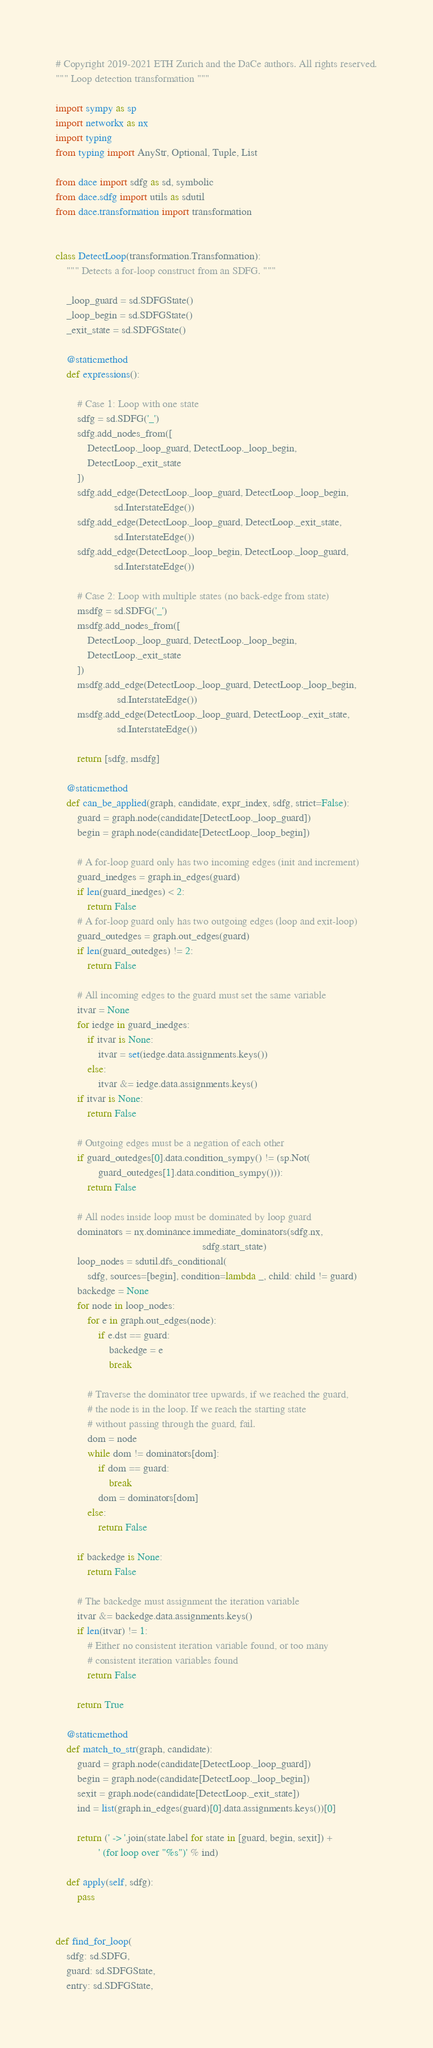Convert code to text. <code><loc_0><loc_0><loc_500><loc_500><_Python_># Copyright 2019-2021 ETH Zurich and the DaCe authors. All rights reserved.
""" Loop detection transformation """

import sympy as sp
import networkx as nx
import typing
from typing import AnyStr, Optional, Tuple, List

from dace import sdfg as sd, symbolic
from dace.sdfg import utils as sdutil
from dace.transformation import transformation


class DetectLoop(transformation.Transformation):
    """ Detects a for-loop construct from an SDFG. """

    _loop_guard = sd.SDFGState()
    _loop_begin = sd.SDFGState()
    _exit_state = sd.SDFGState()

    @staticmethod
    def expressions():

        # Case 1: Loop with one state
        sdfg = sd.SDFG('_')
        sdfg.add_nodes_from([
            DetectLoop._loop_guard, DetectLoop._loop_begin,
            DetectLoop._exit_state
        ])
        sdfg.add_edge(DetectLoop._loop_guard, DetectLoop._loop_begin,
                      sd.InterstateEdge())
        sdfg.add_edge(DetectLoop._loop_guard, DetectLoop._exit_state,
                      sd.InterstateEdge())
        sdfg.add_edge(DetectLoop._loop_begin, DetectLoop._loop_guard,
                      sd.InterstateEdge())

        # Case 2: Loop with multiple states (no back-edge from state)
        msdfg = sd.SDFG('_')
        msdfg.add_nodes_from([
            DetectLoop._loop_guard, DetectLoop._loop_begin,
            DetectLoop._exit_state
        ])
        msdfg.add_edge(DetectLoop._loop_guard, DetectLoop._loop_begin,
                       sd.InterstateEdge())
        msdfg.add_edge(DetectLoop._loop_guard, DetectLoop._exit_state,
                       sd.InterstateEdge())

        return [sdfg, msdfg]

    @staticmethod
    def can_be_applied(graph, candidate, expr_index, sdfg, strict=False):
        guard = graph.node(candidate[DetectLoop._loop_guard])
        begin = graph.node(candidate[DetectLoop._loop_begin])

        # A for-loop guard only has two incoming edges (init and increment)
        guard_inedges = graph.in_edges(guard)
        if len(guard_inedges) < 2:
            return False
        # A for-loop guard only has two outgoing edges (loop and exit-loop)
        guard_outedges = graph.out_edges(guard)
        if len(guard_outedges) != 2:
            return False

        # All incoming edges to the guard must set the same variable
        itvar = None
        for iedge in guard_inedges:
            if itvar is None:
                itvar = set(iedge.data.assignments.keys())
            else:
                itvar &= iedge.data.assignments.keys()
        if itvar is None:
            return False

        # Outgoing edges must be a negation of each other
        if guard_outedges[0].data.condition_sympy() != (sp.Not(
                guard_outedges[1].data.condition_sympy())):
            return False

        # All nodes inside loop must be dominated by loop guard
        dominators = nx.dominance.immediate_dominators(sdfg.nx,
                                                       sdfg.start_state)
        loop_nodes = sdutil.dfs_conditional(
            sdfg, sources=[begin], condition=lambda _, child: child != guard)
        backedge = None
        for node in loop_nodes:
            for e in graph.out_edges(node):
                if e.dst == guard:
                    backedge = e
                    break

            # Traverse the dominator tree upwards, if we reached the guard,
            # the node is in the loop. If we reach the starting state
            # without passing through the guard, fail.
            dom = node
            while dom != dominators[dom]:
                if dom == guard:
                    break
                dom = dominators[dom]
            else:
                return False

        if backedge is None:
            return False

        # The backedge must assignment the iteration variable
        itvar &= backedge.data.assignments.keys()
        if len(itvar) != 1:
            # Either no consistent iteration variable found, or too many
            # consistent iteration variables found
            return False

        return True

    @staticmethod
    def match_to_str(graph, candidate):
        guard = graph.node(candidate[DetectLoop._loop_guard])
        begin = graph.node(candidate[DetectLoop._loop_begin])
        sexit = graph.node(candidate[DetectLoop._exit_state])
        ind = list(graph.in_edges(guard)[0].data.assignments.keys())[0]

        return (' -> '.join(state.label for state in [guard, begin, sexit]) +
                ' (for loop over "%s")' % ind)

    def apply(self, sdfg):
        pass


def find_for_loop(
    sdfg: sd.SDFG,
    guard: sd.SDFGState,
    entry: sd.SDFGState,</code> 